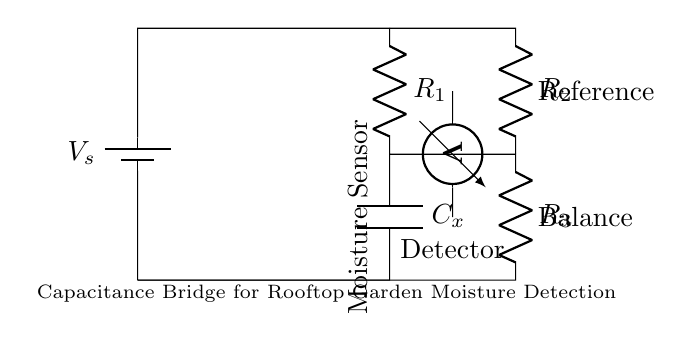What is the component labeled Cx? The component labeled Cx is a capacitor, denoted in the diagram by the symbol 'C'. Capacitors are typically used to store electrical energy and can be used in circuits to detect changes in moisture levels in this context.
Answer: capacitor What does Rs represent in this circuit? Rs in the circuit is a symbol for a resistor. Resistors limit the flow of electric current and are used for various purposes such as setting bias points or forming voltage dividers. Here, it is likely part of balancing the bridge.
Answer: resistor How many resistors are present in the circuit? The circuit contains three resistors labeled as R1, R2, and R3. Counting these components provides an understanding of how the circuit maintains balance by adjusting resistance.
Answer: three What is the role of the voltmeter in this circuit? The voltmeter is used to measure the voltage difference across specific points in the circuit, which is crucial for determining the balance in the capacitance bridge. This measurement helps assess the moisture level by detecting fluctuations in voltage.
Answer: voltage measurement What does the moisture sensor do in this circuit? The moisture sensor detects changes in moisture levels, which affects the capacitance of the capacitor Cx. By measuring these changes, the circuit can effectively monitor moisture in the rooftop garden or green space.
Answer: moisture detection What is the purpose of the capacitance bridge circuit? The purpose of the capacitance bridge circuit is to measure the capacitance changes due to moisture levels in the soil of rooftop gardens. It balances out the resistances and allows for precise detection relevant for irrigation decisions.
Answer: moisture measurement What is the connection type between the battery and the resistors? The connection type between the battery and the resistors is a series connection, as all components are arranged in a single path for current. This layout is essential for maintaining a consistent voltage drop across the circuit elements.
Answer: series connection 